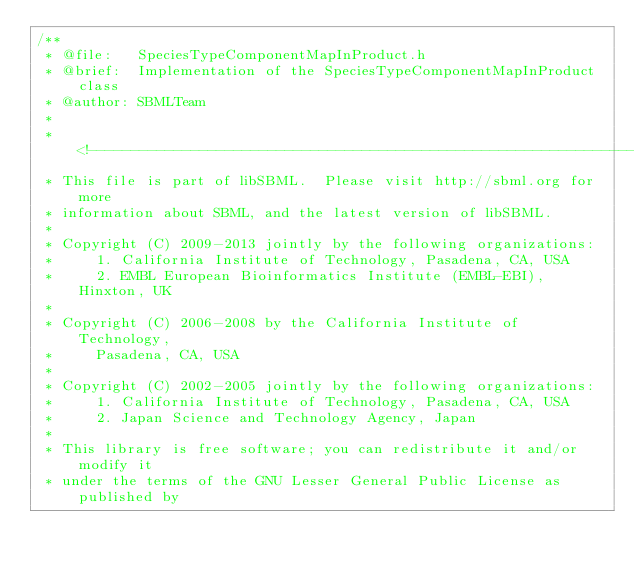Convert code to text. <code><loc_0><loc_0><loc_500><loc_500><_C_>/**
 * @file:   SpeciesTypeComponentMapInProduct.h
 * @brief:  Implementation of the SpeciesTypeComponentMapInProduct class
 * @author: SBMLTeam
 *
 * <!--------------------------------------------------------------------------
 * This file is part of libSBML.  Please visit http://sbml.org for more
 * information about SBML, and the latest version of libSBML.
 *
 * Copyright (C) 2009-2013 jointly by the following organizations:
 *     1. California Institute of Technology, Pasadena, CA, USA
 *     2. EMBL European Bioinformatics Institute (EMBL-EBI), Hinxton, UK
 *
 * Copyright (C) 2006-2008 by the California Institute of Technology,
 *     Pasadena, CA, USA 
 *
 * Copyright (C) 2002-2005 jointly by the following organizations:
 *     1. California Institute of Technology, Pasadena, CA, USA
 *     2. Japan Science and Technology Agency, Japan
 *
 * This library is free software; you can redistribute it and/or modify it
 * under the terms of the GNU Lesser General Public License as published by</code> 